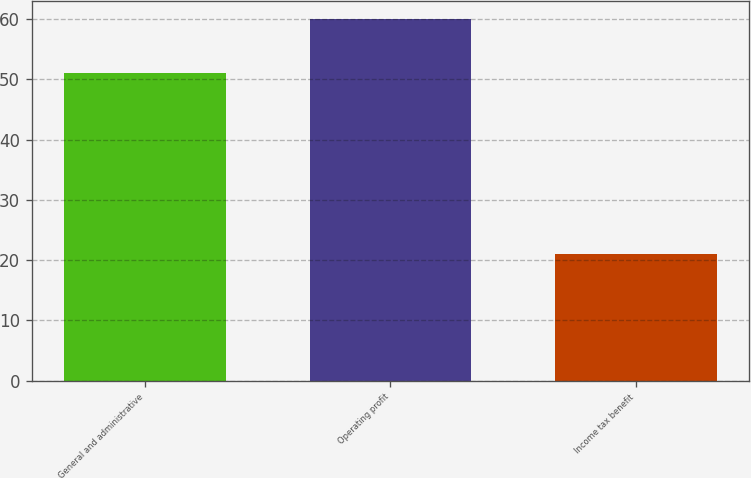<chart> <loc_0><loc_0><loc_500><loc_500><bar_chart><fcel>General and administrative<fcel>Operating profit<fcel>Income tax benefit<nl><fcel>51<fcel>60<fcel>21<nl></chart> 